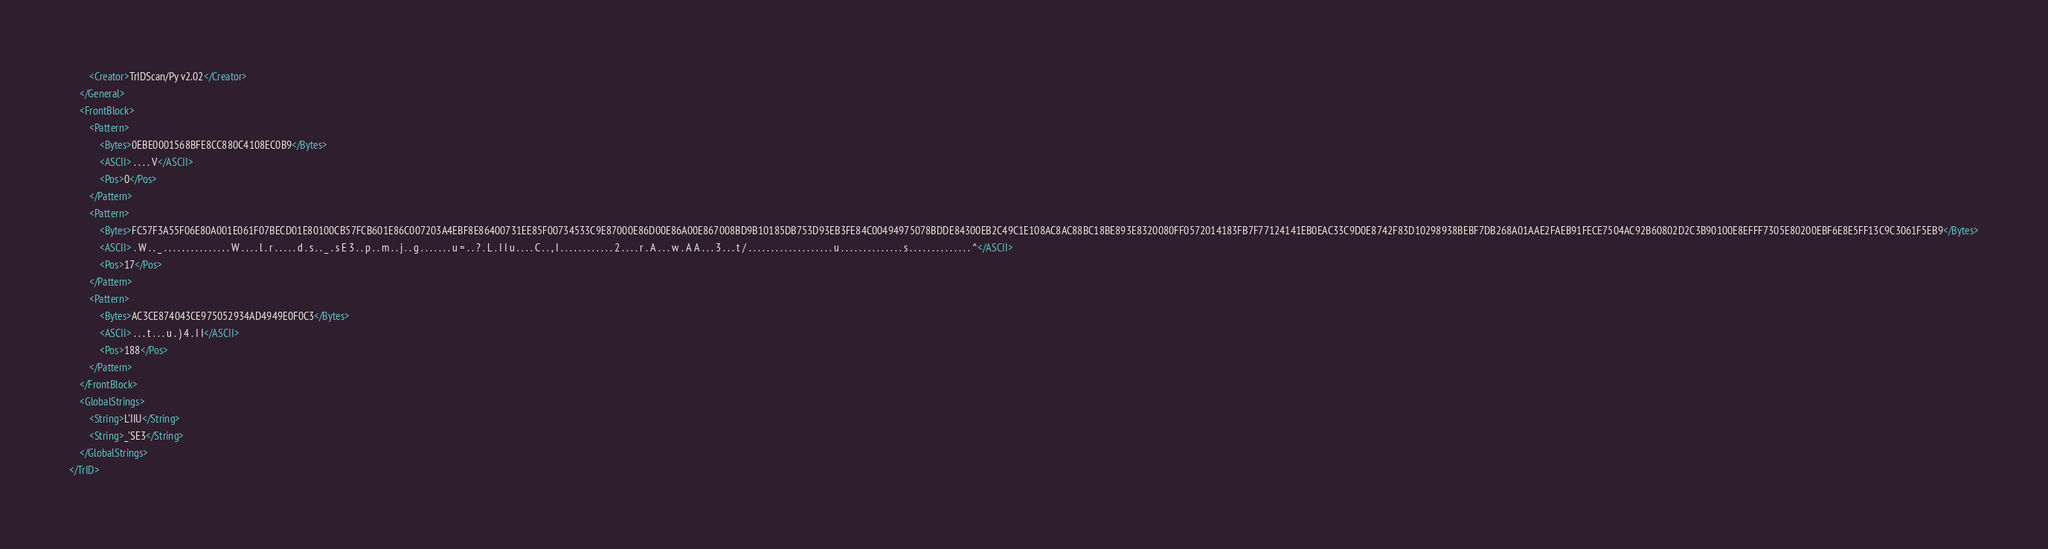<code> <loc_0><loc_0><loc_500><loc_500><_XML_>		<Creator>TrIDScan/Py v2.02</Creator>
	</General>
	<FrontBlock>
		<Pattern>
			<Bytes>0EBE0001568BFE8CC880C4108EC0B9</Bytes>
			<ASCII> . . . . V</ASCII>
			<Pos>0</Pos>
		</Pattern>
		<Pattern>
			<Bytes>FC57F3A55F06E80A001E061F07BECD01E80100CB57FCB601E86C007203A4EBF8E86400731EE85F00734533C9E87000E86D00E86A00E867008BD9B10185DB753D93EB3FE84C00494975078BDDE84300EB2C49C1E108AC8AC88BC18BE893E8320080FF0572014183FB7F77124141EB0EAC33C9D0E8742F83D10298938BEBF7DB268A01AAE2FAEB91FECE7504AC92B60802D2C3B90100E8EFFF7305E80200EBF6E8E5FF13C9C3061F5EB9</Bytes>
			<ASCII> . W . . _ . . . . . . . . . . . . . . . W . . . . l . r . . . . . d . s . . _ . s E 3 . . p . . m . . j . . g . . . . . . . u = . . ? . L . I I u . . . . C . . , I . . . . . . . . . . . . 2 . . . . r . A . . . w . A A . . . 3 . . . t / . . . . . . . . . . . . . . . . . . . u . . . . . . . . . . . . . . s . . . . . . . . . . . . . . ^</ASCII>
			<Pos>17</Pos>
		</Pattern>
		<Pattern>
			<Bytes>AC3CE874043CE975052934AD4949E0F0C3</Bytes>
			<ASCII> . . . t . . . u . ) 4 . I I</ASCII>
			<Pos>188</Pos>
		</Pattern>
	</FrontBlock>
	<GlobalStrings>
		<String>L'IIU</String>
		<String>_'SE3</String>
	</GlobalStrings>
</TrID></code> 